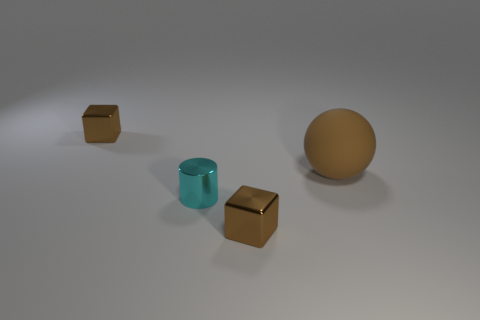What number of brown shiny things are right of the small cyan thing and behind the tiny cyan metal object?
Your answer should be very brief. 0. What is the shape of the tiny brown shiny thing behind the tiny metallic cylinder?
Make the answer very short. Cube. How many cyan cylinders have the same material as the sphere?
Ensure brevity in your answer.  0. Does the cyan metal thing have the same shape as the shiny thing that is behind the brown rubber sphere?
Provide a short and direct response. No. There is a brown cube that is left of the small shiny block that is in front of the cyan object; is there a cube that is on the right side of it?
Your answer should be very brief. Yes. What is the size of the metal cube that is behind the brown matte ball?
Provide a short and direct response. Small. Is the shape of the big brown rubber thing the same as the cyan shiny object?
Ensure brevity in your answer.  No. What number of objects are tiny green rubber things or things behind the large rubber thing?
Keep it short and to the point. 1. There is a brown metallic block left of the shiny cylinder; is it the same size as the small cyan metal cylinder?
Provide a succinct answer. Yes. How many tiny shiny cylinders are to the right of the metallic cube left of the small brown metallic thing to the right of the cyan metal object?
Offer a terse response. 1. 